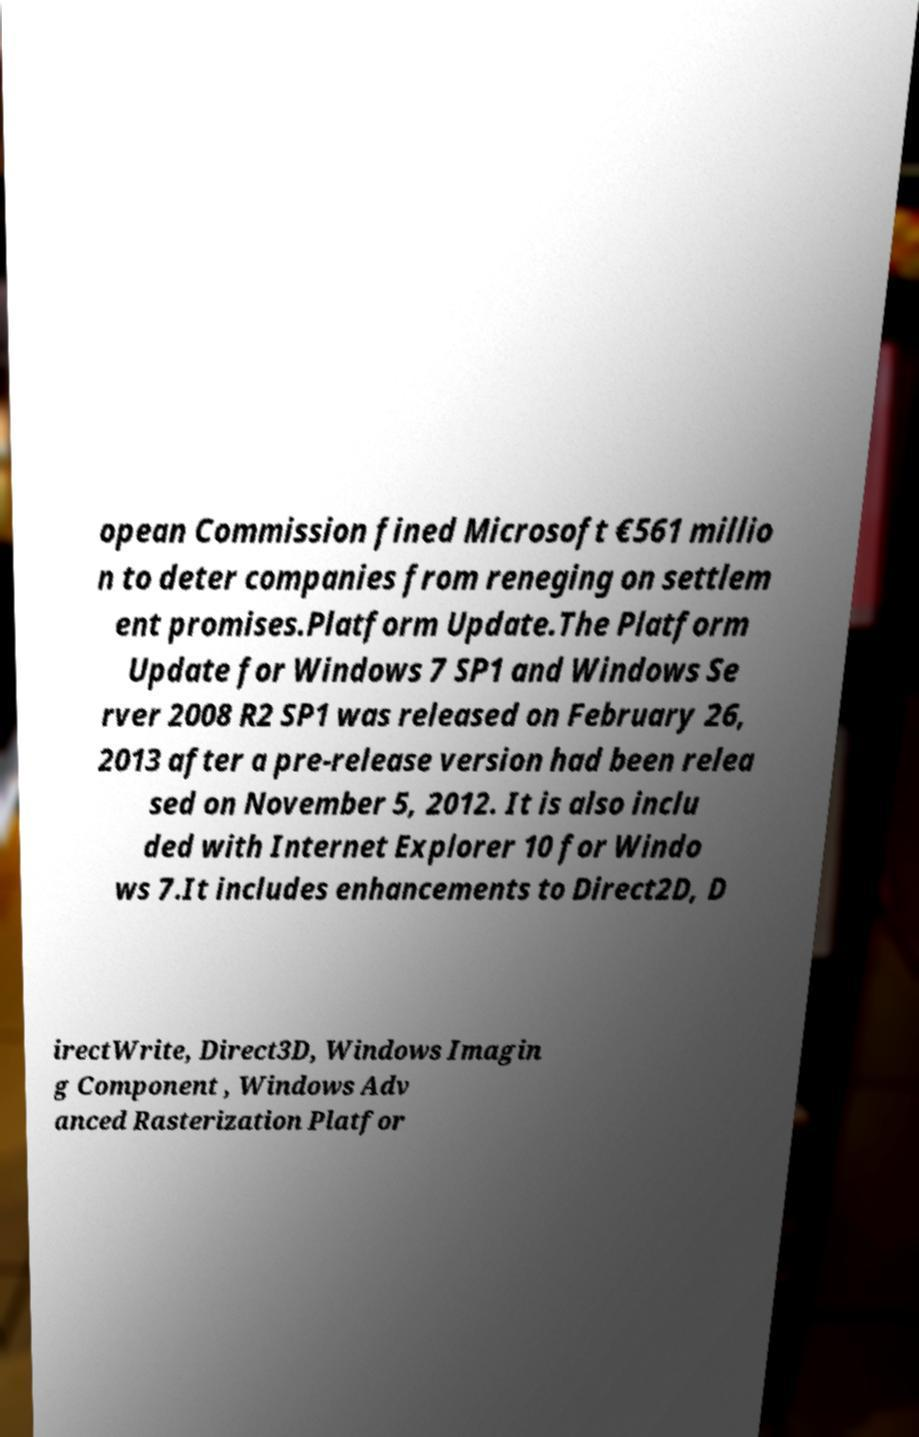Please read and relay the text visible in this image. What does it say? opean Commission fined Microsoft €561 millio n to deter companies from reneging on settlem ent promises.Platform Update.The Platform Update for Windows 7 SP1 and Windows Se rver 2008 R2 SP1 was released on February 26, 2013 after a pre-release version had been relea sed on November 5, 2012. It is also inclu ded with Internet Explorer 10 for Windo ws 7.It includes enhancements to Direct2D, D irectWrite, Direct3D, Windows Imagin g Component , Windows Adv anced Rasterization Platfor 